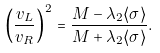Convert formula to latex. <formula><loc_0><loc_0><loc_500><loc_500>\left ( \frac { v _ { L } } { v _ { R } } \right ) ^ { 2 } = \frac { M - \lambda _ { 2 } \langle \sigma \rangle } { M + \lambda _ { 2 } \langle \sigma \rangle } .</formula> 